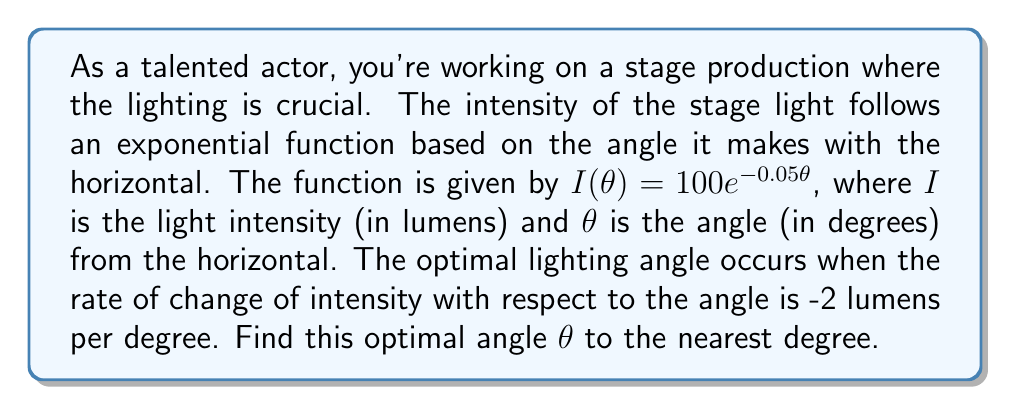Show me your answer to this math problem. To solve this problem, we need to use the concept of derivatives in exponential functions and first-order differential equations. Let's approach this step-by-step:

1) We're given the function $I(\theta) = 100e^{-0.05\theta}$

2) We need to find the rate of change of intensity with respect to the angle, which is the derivative $\frac{dI}{d\theta}$

3) Using the chain rule, we can differentiate the function:

   $$\frac{dI}{d\theta} = 100 \cdot (-0.05) \cdot e^{-0.05\theta} = -5e^{-0.05\theta}$$

4) We're told that the optimal angle occurs when this rate of change equals -2 lumens per degree. So we can set up the equation:

   $$-5e^{-0.05\theta} = -2$$

5) To solve for $\theta$, let's first divide both sides by -5:

   $$e^{-0.05\theta} = \frac{2}{5} = 0.4$$

6) Now, we can take the natural logarithm of both sides:

   $$-0.05\theta = \ln(0.4)$$

7) Solving for $\theta$:

   $$\theta = -\frac{\ln(0.4)}{0.05}$$

8) Using a calculator or computer:

   $$\theta \approx 18.3$$

9) Rounding to the nearest degree, we get 18°.
Answer: 18° 